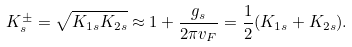<formula> <loc_0><loc_0><loc_500><loc_500>K _ { s } ^ { \pm } = \sqrt { K _ { 1 s } K _ { 2 s } } \approx 1 + \frac { g _ { s } } { 2 \pi v _ { F } } = \frac { 1 } { 2 } ( K _ { 1 s } + K _ { 2 s } ) .</formula> 